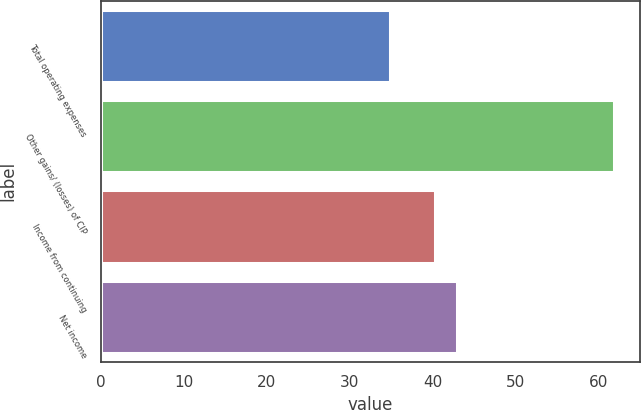Convert chart to OTSL. <chart><loc_0><loc_0><loc_500><loc_500><bar_chart><fcel>Total operating expenses<fcel>Other gains/ (losses) of CIP<fcel>Income from continuing<fcel>Net income<nl><fcel>34.9<fcel>61.9<fcel>40.3<fcel>43<nl></chart> 